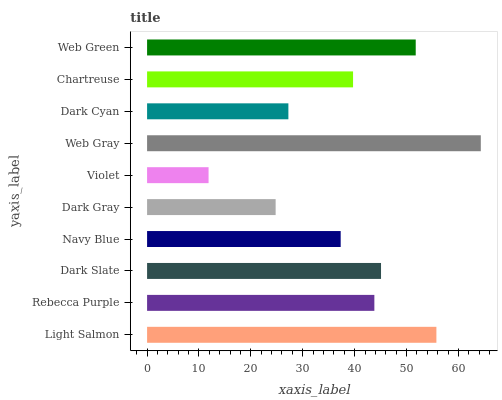Is Violet the minimum?
Answer yes or no. Yes. Is Web Gray the maximum?
Answer yes or no. Yes. Is Rebecca Purple the minimum?
Answer yes or no. No. Is Rebecca Purple the maximum?
Answer yes or no. No. Is Light Salmon greater than Rebecca Purple?
Answer yes or no. Yes. Is Rebecca Purple less than Light Salmon?
Answer yes or no. Yes. Is Rebecca Purple greater than Light Salmon?
Answer yes or no. No. Is Light Salmon less than Rebecca Purple?
Answer yes or no. No. Is Rebecca Purple the high median?
Answer yes or no. Yes. Is Chartreuse the low median?
Answer yes or no. Yes. Is Dark Slate the high median?
Answer yes or no. No. Is Web Green the low median?
Answer yes or no. No. 